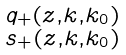<formula> <loc_0><loc_0><loc_500><loc_500>\begin{smallmatrix} q _ { + } ( z , k , k _ { 0 } ) \\ s _ { + } ( z , k , k _ { 0 } ) \end{smallmatrix}</formula> 